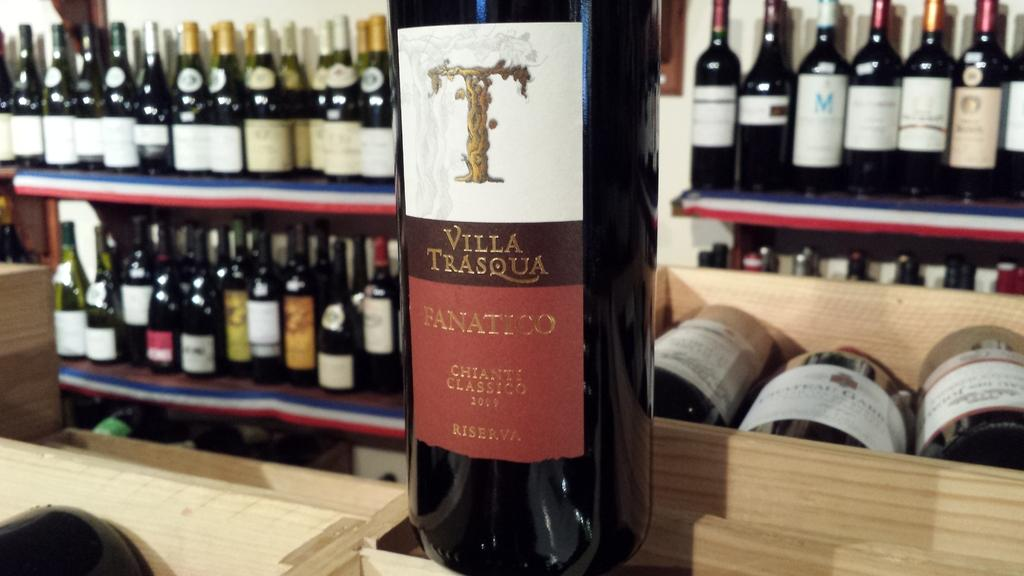<image>
Provide a brief description of the given image. A bottle of Villa Trasqua Fanatico sits in front of numerous bottles of wine. 